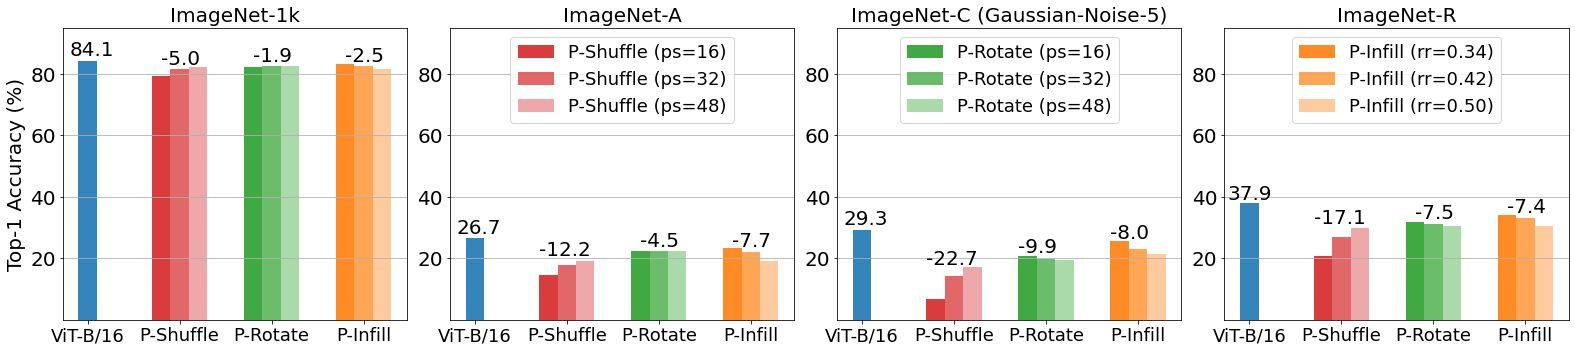Can you explain why P-Rotate with ps=16 is more effective than P-Rotate with ps=32 under the Gaussian-Noise-5 condition on ImageNet-C? The effectiveness of P-Rotate with ps=16 over ps=32 in the given scenario likely stems from the granularity of the rotation. Smaller partition sizes such as ps=16 allow for more localized and controlled adjustments, reducing the extent of disruption across the image. This contrasts with larger partitions like ps=32, where broader rotations might distort more critical image features, leading to higher error rates. 